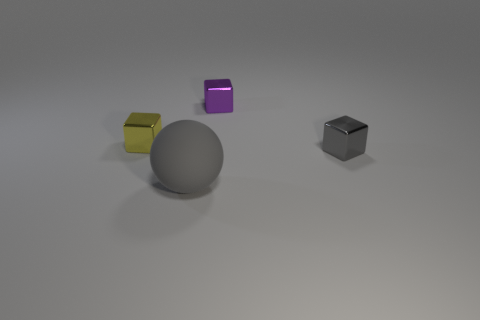Is there anything else that has the same size as the gray rubber sphere?
Keep it short and to the point. No. Is there any other thing that is the same material as the large gray thing?
Provide a short and direct response. No. Do the thing that is in front of the small gray object and the small block that is to the left of the big ball have the same material?
Offer a very short reply. No. Is there a big blue ball?
Provide a succinct answer. No. Does the gray object in front of the gray cube have the same shape as the gray thing that is behind the gray ball?
Ensure brevity in your answer.  No. Are there any tiny brown objects made of the same material as the yellow cube?
Your answer should be very brief. No. Is the material of the gray thing that is on the right side of the big gray rubber object the same as the sphere?
Your answer should be compact. No. Is the number of tiny gray things that are in front of the yellow block greater than the number of gray spheres on the right side of the large gray ball?
Your answer should be very brief. Yes. Is there another rubber thing of the same color as the matte object?
Your response must be concise. No. Do the metallic thing on the left side of the big gray matte sphere and the object in front of the gray metal block have the same color?
Make the answer very short. No. 